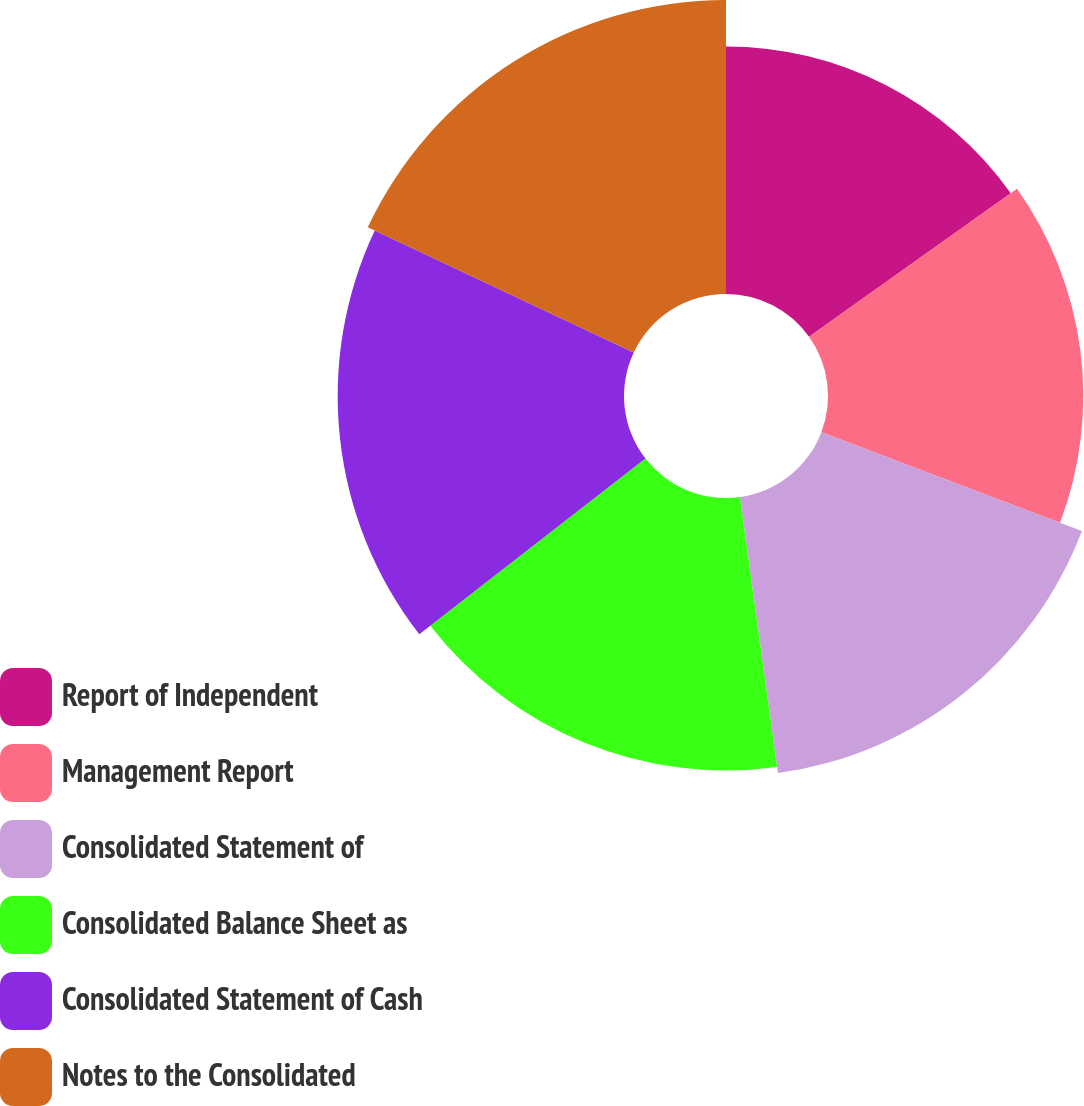Convert chart to OTSL. <chart><loc_0><loc_0><loc_500><loc_500><pie_chart><fcel>Report of Independent<fcel>Management Report<fcel>Consolidated Statement of<fcel>Consolidated Balance Sheet as<fcel>Consolidated Statement of Cash<fcel>Notes to the Consolidated<nl><fcel>15.15%<fcel>15.62%<fcel>17.05%<fcel>16.67%<fcel>17.52%<fcel>17.99%<nl></chart> 